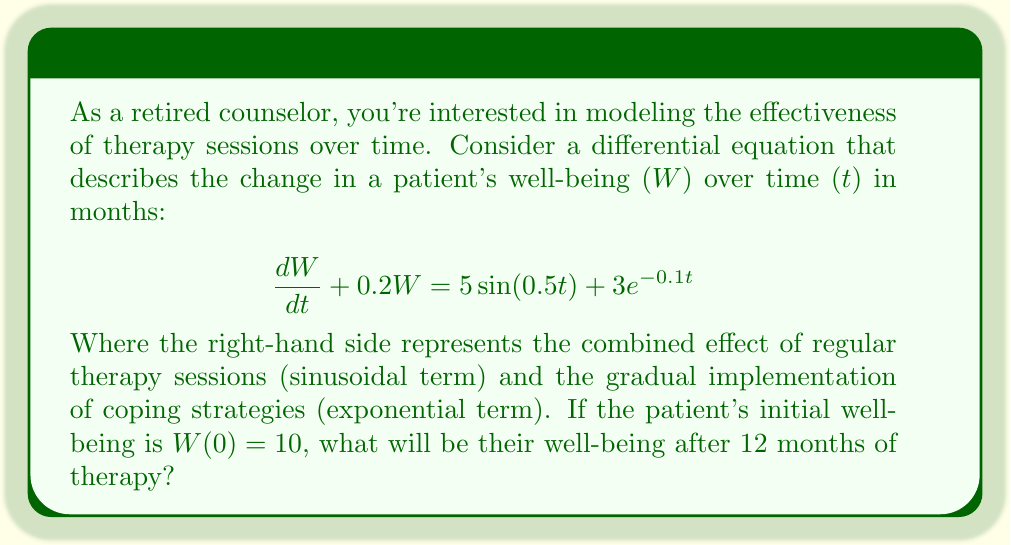Solve this math problem. To solve this first-order linear differential equation, we'll use the integrating factor method:

1) The equation is in the form $\frac{dW}{dt} + P(t)W = Q(t)$, where $P(t) = 0.2$ and $Q(t) = 5\sin(0.5t) + 3e^{-0.1t}$.

2) The integrating factor is $\mu(t) = e^{\int P(t) dt} = e^{0.2t}$.

3) Multiply both sides of the equation by $\mu(t)$:

   $$e^{0.2t}\frac{dW}{dt} + 0.2e^{0.2t}W = 5e^{0.2t}\sin(0.5t) + 3e^{0.1t}$$

4) The left side is now the derivative of $e^{0.2t}W$. Integrate both sides:

   $$e^{0.2t}W = \int (5e^{0.2t}\sin(0.5t) + 3e^{0.1t}) dt + C$$

5) Evaluate the integrals:

   $$e^{0.2t}W = 5\frac{e^{0.2t}(0.2\sin(0.5t) - 0.5\cos(0.5t))}{0.04 + 0.25} + 30e^{0.1t} + C$$

6) Solve for $W$:

   $$W = 5\frac{0.2\sin(0.5t) - 0.5\cos(0.5t)}{0.29} + 30e^{-0.1t} + Ce^{-0.2t}$$

7) Use the initial condition $W(0) = 10$ to find $C$:

   $$10 = 5\frac{-0.5}{0.29} + 30 + C$$
   $$C = 10 - 30 + 5\frac{0.5}{0.29} \approx -11.38$$

8) The final solution is:

   $$W(t) = 5\frac{0.2\sin(0.5t) - 0.5\cos(0.5t)}{0.29} + 30e^{-0.1t} - 11.38e^{-0.2t}$$

9) To find $W(12)$, substitute $t = 12$ into this expression.
Answer: $W(12) \approx 21.37$ 